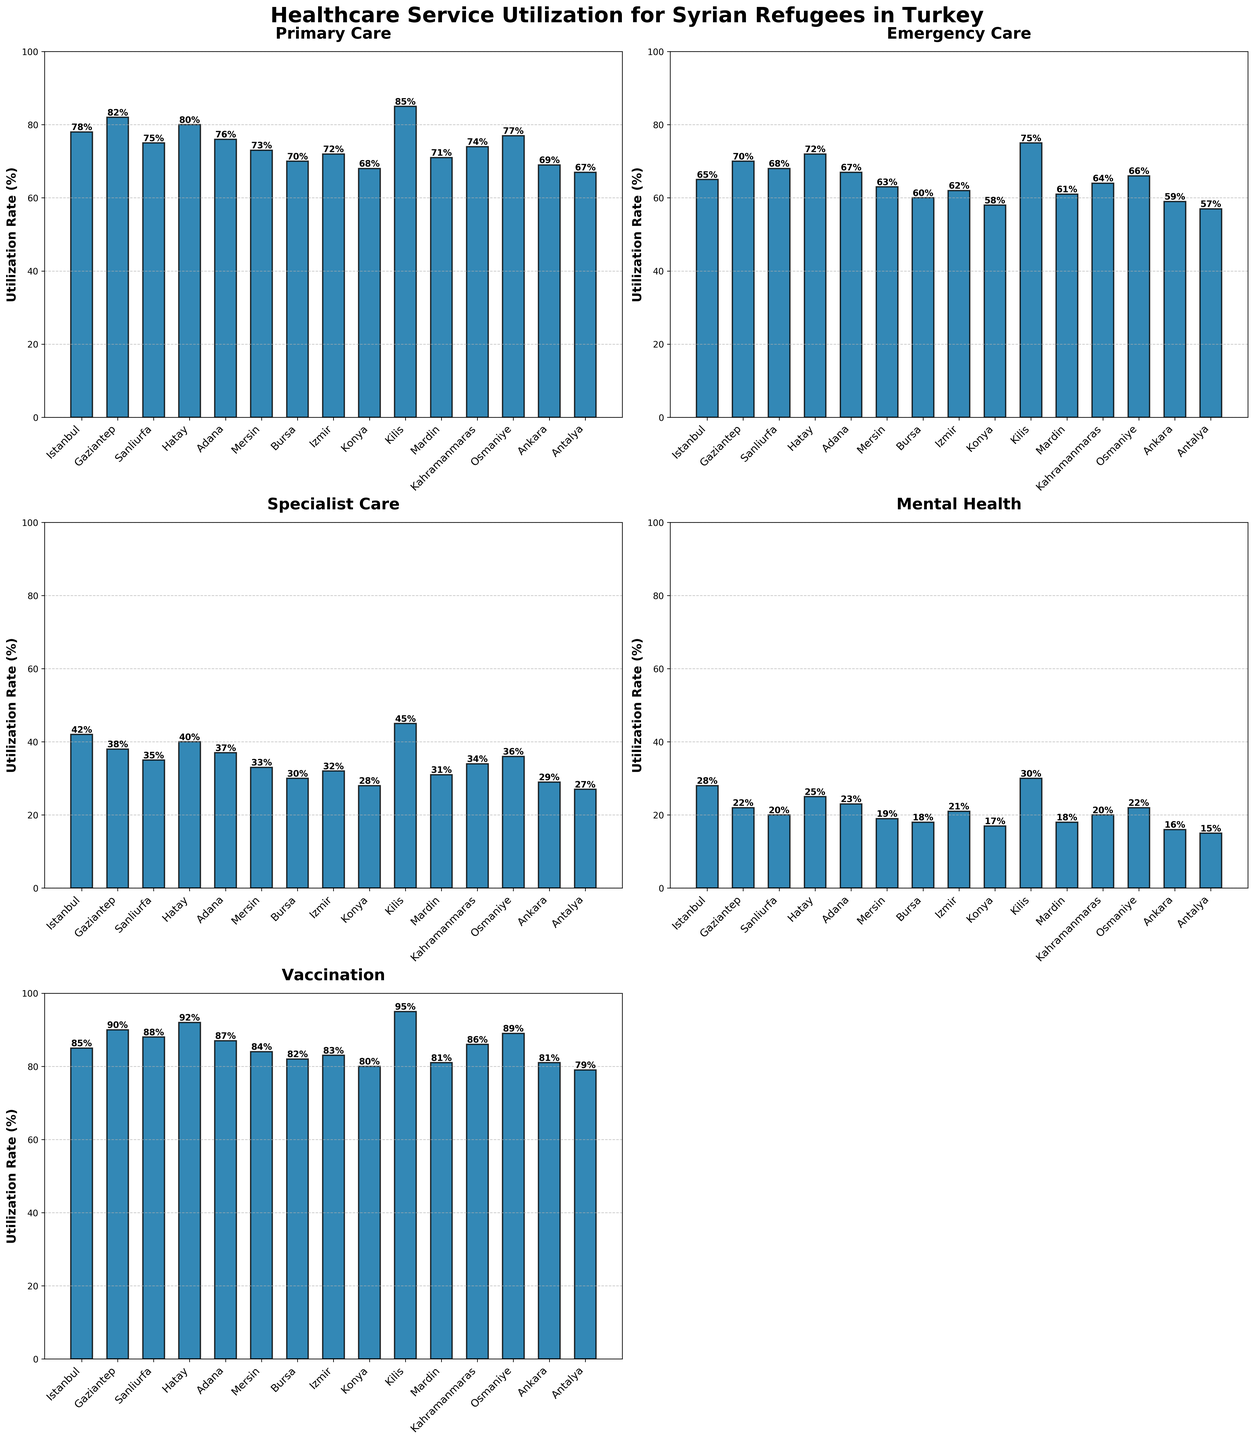What's the highest utilization rate of Primary Care among the regions? The highest bar in the Primary Care subplot represents the highest utilization rate. Kilis shows the highest utilization rate at 85%.
Answer: 85% Which region has the lowest utilization rate for Mental Health services? The shortest bar in the Mental Health subplot corresponds to the lowest utilization rate. Antalya shows the lowest utilization rate at 15%.
Answer: Antalya Compare the utilization rates of Emergency Care in Istanbul and Konya. Which one is higher? The bar heights in the Emergency Care subplot indicate the utilization rates. In Istanbul, it is 65%, while in Konya it is 58%. So, Istanbul is higher.
Answer: Istanbul What is the average utilization rate of Specialist Care across all regions? Sum the Specialist Care rates (42+38+35+40+37+33+30+32+28+45+31+34+36+29+27), which is 517, and divide by the number of regions (15). The average rate is 517 / 15 = 34.47%.
Answer: 34.47% How does the utilization rate of Vaccination in Mardin compare to that in Hatay? The bar heights in the Vaccination subplot show the rates. In Mardin, it is 81%, and in Hatay, it is 92%, so Mardin has a lower rate.
Answer: Mardin is lower Which region has the highest difference between Primary Care and Mental Health utilization rates? Calculate the differences for each region by subtracting Mental Health from Primary Care. The highest difference is in Kilis with 85 - 30 = 55.
Answer: Kilis By how much does the utilization rate of Primary Care in Gaziantep exceed that in Antalya? Gaziantep's Primary Care rate is 82%, and Antalya’s is 67%. The difference is 82 - 67 = 15%.
Answer: 15% Which region shows the most consistent utilization rates across all healthcare services? A region with bars of nearly the same height in all subplots would be consistent. Gaziantep and Hatay show less variation across all services.
Answer: Gaziantep or Hatay What is the combined utilization rate of Emergency Care and Vaccination in Bursa? Add the bars' values from those subplots for Bursa: 60% (Emergency Care) + 82% (Vaccination) = 142%.
Answer: 142% Which regions have higher utilization rates for Specialist Care compared to Mental Health? Identify regions where the Specialist Care bar is taller than the Mental Health bar. Istanbul (42% vs. 28%), Hatay (40% vs. 25%), Kilis (45% vs. 30%), and Osmaniye (36% vs. 22%) fit this criterion.
Answer: Istanbul, Hatay, Kilis, Osmaniye 